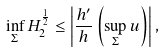<formula> <loc_0><loc_0><loc_500><loc_500>\inf _ { \Sigma } H _ { 2 } ^ { \frac { 1 } { 2 } } \leq \left | \frac { h ^ { \prime } } { h } \left ( \sup _ { \Sigma } u \right ) \right | ,</formula> 